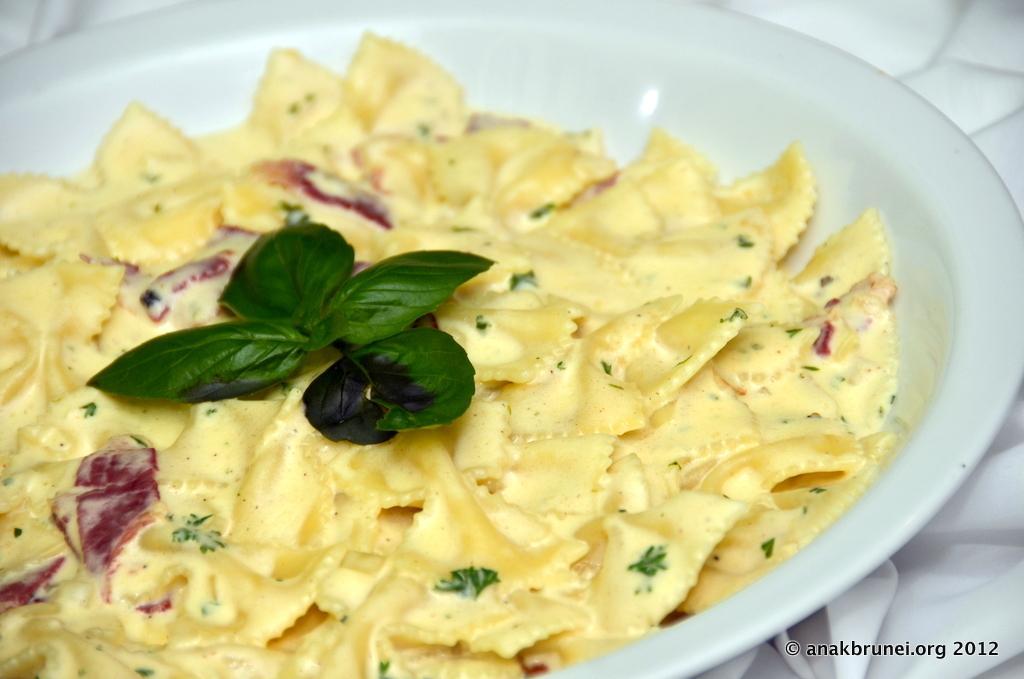In one or two sentences, can you explain what this image depicts? In the picture we can see a plate which is white in color, on it we can see some flakes which are light yellow in color with some leaf garnish on it. 